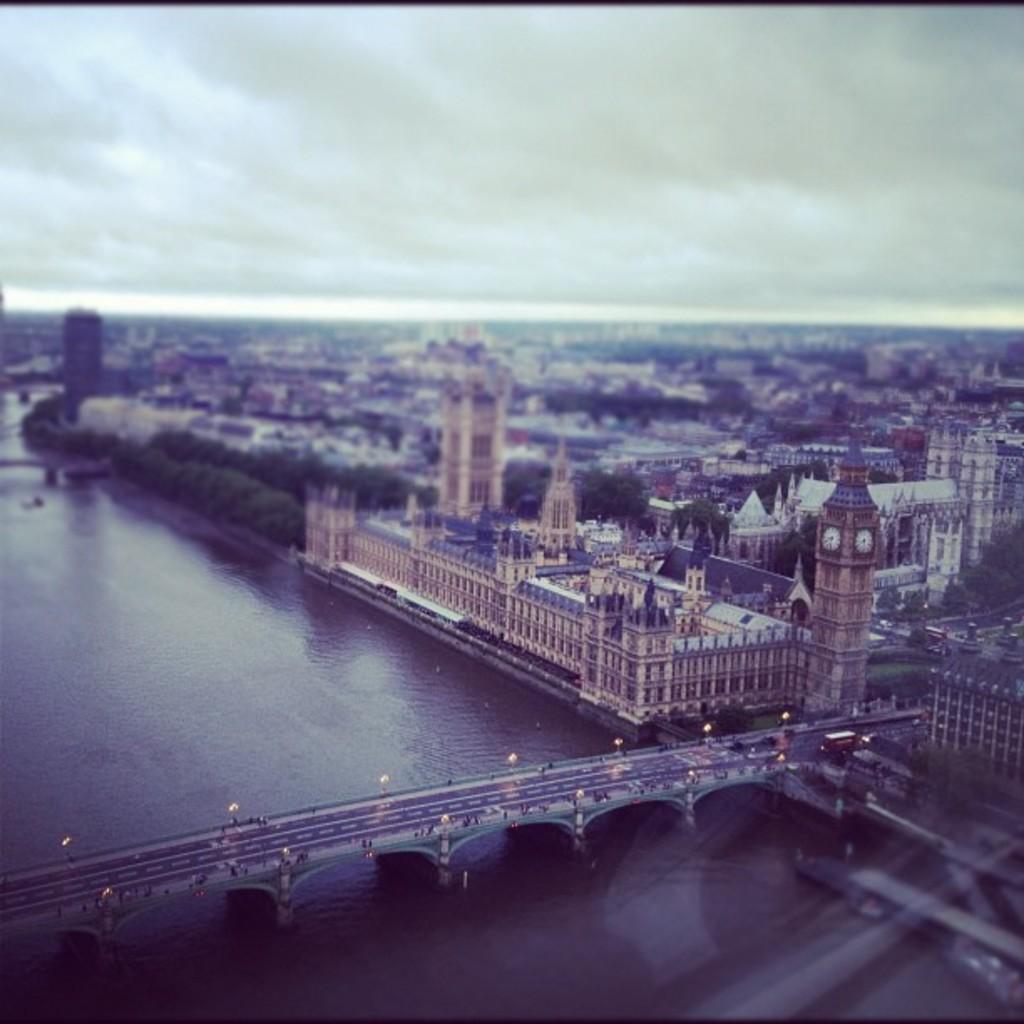Could you give a brief overview of what you see in this image? In the image we can see there are many buildings and trees. We can even see the bridge and on the bridge there are vehicles. Here we can see lights, water and the cloudy sky. The image is slightly blurred. 